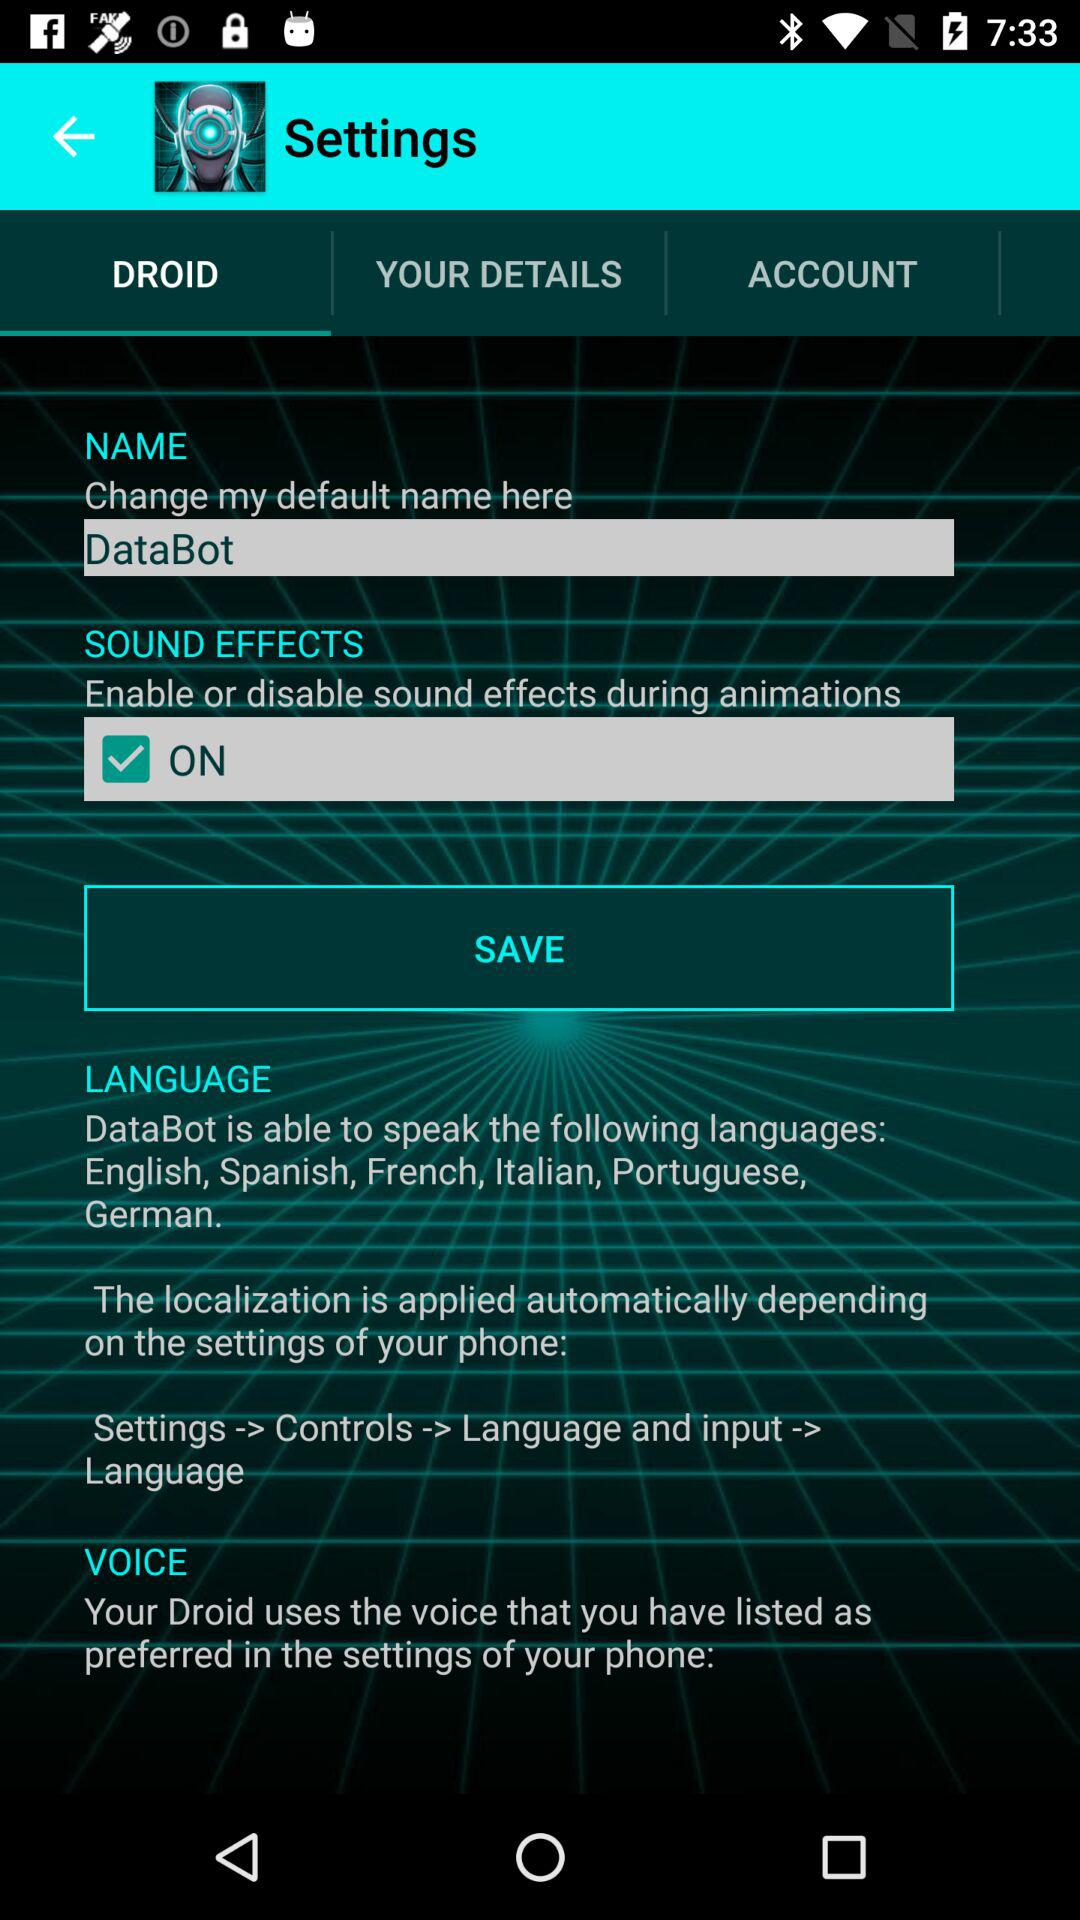How many languages does DataBot speak?
Answer the question using a single word or phrase. 6 